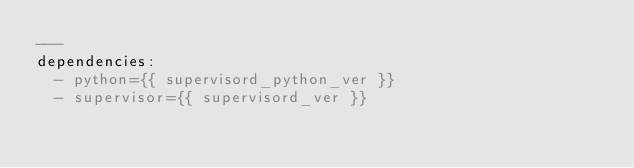Convert code to text. <code><loc_0><loc_0><loc_500><loc_500><_YAML_>---
dependencies:
  - python={{ supervisord_python_ver }}
  - supervisor={{ supervisord_ver }}

</code> 